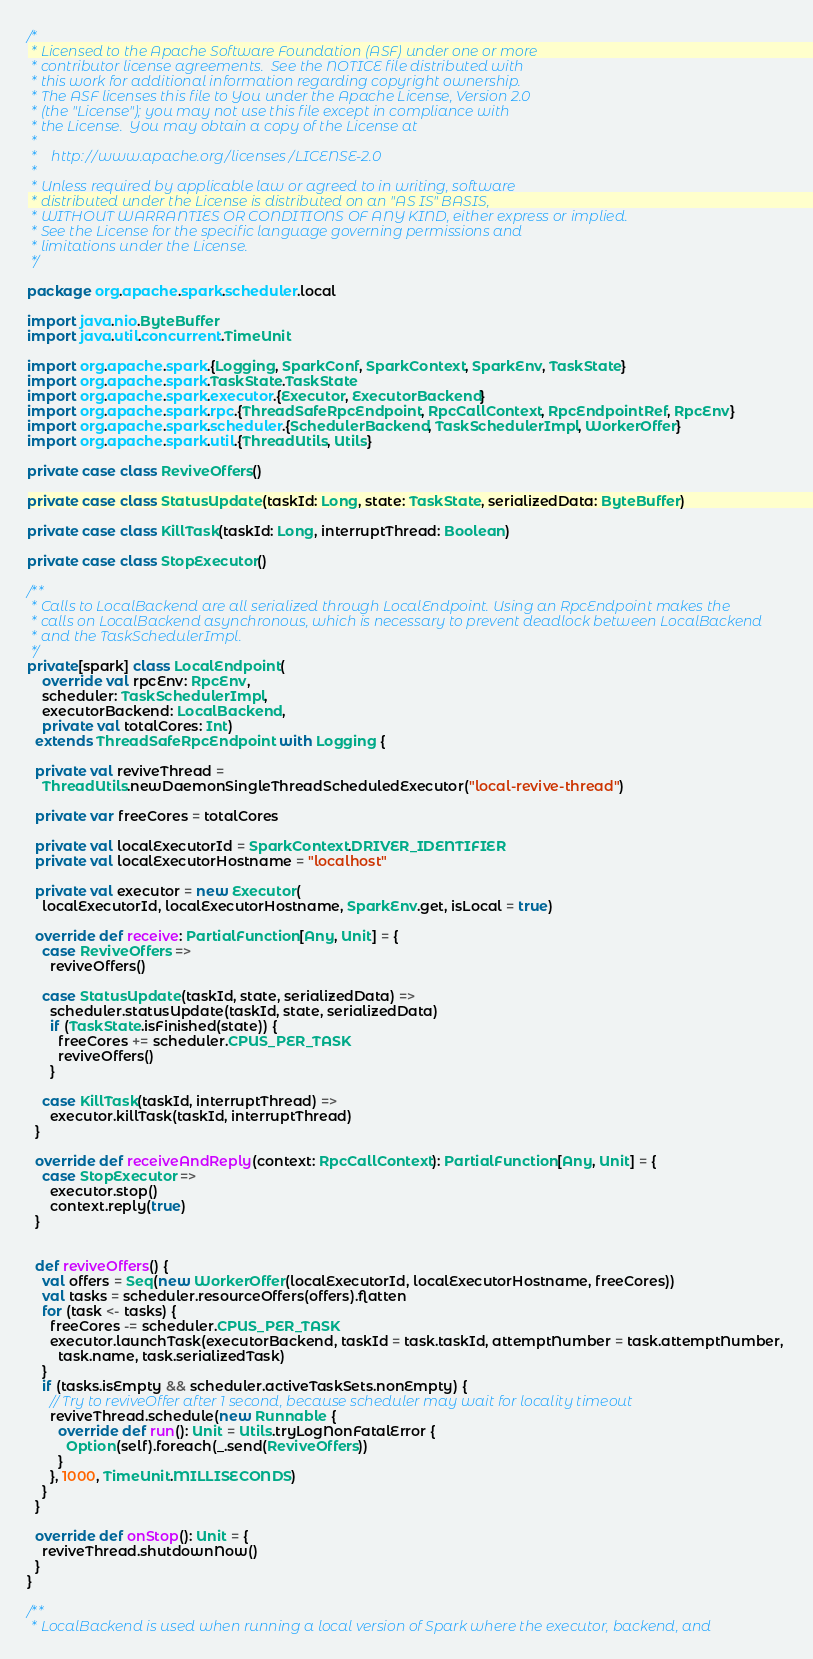Convert code to text. <code><loc_0><loc_0><loc_500><loc_500><_Scala_>/*
 * Licensed to the Apache Software Foundation (ASF) under one or more
 * contributor license agreements.  See the NOTICE file distributed with
 * this work for additional information regarding copyright ownership.
 * The ASF licenses this file to You under the Apache License, Version 2.0
 * (the "License"); you may not use this file except in compliance with
 * the License.  You may obtain a copy of the License at
 *
 *    http://www.apache.org/licenses/LICENSE-2.0
 *
 * Unless required by applicable law or agreed to in writing, software
 * distributed under the License is distributed on an "AS IS" BASIS,
 * WITHOUT WARRANTIES OR CONDITIONS OF ANY KIND, either express or implied.
 * See the License for the specific language governing permissions and
 * limitations under the License.
 */

package org.apache.spark.scheduler.local

import java.nio.ByteBuffer
import java.util.concurrent.TimeUnit

import org.apache.spark.{Logging, SparkConf, SparkContext, SparkEnv, TaskState}
import org.apache.spark.TaskState.TaskState
import org.apache.spark.executor.{Executor, ExecutorBackend}
import org.apache.spark.rpc.{ThreadSafeRpcEndpoint, RpcCallContext, RpcEndpointRef, RpcEnv}
import org.apache.spark.scheduler.{SchedulerBackend, TaskSchedulerImpl, WorkerOffer}
import org.apache.spark.util.{ThreadUtils, Utils}

private case class ReviveOffers()

private case class StatusUpdate(taskId: Long, state: TaskState, serializedData: ByteBuffer)

private case class KillTask(taskId: Long, interruptThread: Boolean)

private case class StopExecutor()

/**
 * Calls to LocalBackend are all serialized through LocalEndpoint. Using an RpcEndpoint makes the
 * calls on LocalBackend asynchronous, which is necessary to prevent deadlock between LocalBackend
 * and the TaskSchedulerImpl.
 */
private[spark] class LocalEndpoint(
    override val rpcEnv: RpcEnv,
    scheduler: TaskSchedulerImpl,
    executorBackend: LocalBackend,
    private val totalCores: Int)
  extends ThreadSafeRpcEndpoint with Logging {

  private val reviveThread =
    ThreadUtils.newDaemonSingleThreadScheduledExecutor("local-revive-thread")

  private var freeCores = totalCores

  private val localExecutorId = SparkContext.DRIVER_IDENTIFIER
  private val localExecutorHostname = "localhost"

  private val executor = new Executor(
    localExecutorId, localExecutorHostname, SparkEnv.get, isLocal = true)

  override def receive: PartialFunction[Any, Unit] = {
    case ReviveOffers =>
      reviveOffers()

    case StatusUpdate(taskId, state, serializedData) =>
      scheduler.statusUpdate(taskId, state, serializedData)
      if (TaskState.isFinished(state)) {
        freeCores += scheduler.CPUS_PER_TASK
        reviveOffers()
      }

    case KillTask(taskId, interruptThread) =>
      executor.killTask(taskId, interruptThread)
  }

  override def receiveAndReply(context: RpcCallContext): PartialFunction[Any, Unit] = {
    case StopExecutor =>
      executor.stop()
      context.reply(true)
  }


  def reviveOffers() {
    val offers = Seq(new WorkerOffer(localExecutorId, localExecutorHostname, freeCores))
    val tasks = scheduler.resourceOffers(offers).flatten
    for (task <- tasks) {
      freeCores -= scheduler.CPUS_PER_TASK
      executor.launchTask(executorBackend, taskId = task.taskId, attemptNumber = task.attemptNumber,
        task.name, task.serializedTask)
    }
    if (tasks.isEmpty && scheduler.activeTaskSets.nonEmpty) {
      // Try to reviveOffer after 1 second, because scheduler may wait for locality timeout
      reviveThread.schedule(new Runnable {
        override def run(): Unit = Utils.tryLogNonFatalError {
          Option(self).foreach(_.send(ReviveOffers))
        }
      }, 1000, TimeUnit.MILLISECONDS)
    }
  }

  override def onStop(): Unit = {
    reviveThread.shutdownNow()
  }
}

/**
 * LocalBackend is used when running a local version of Spark where the executor, backend, and</code> 